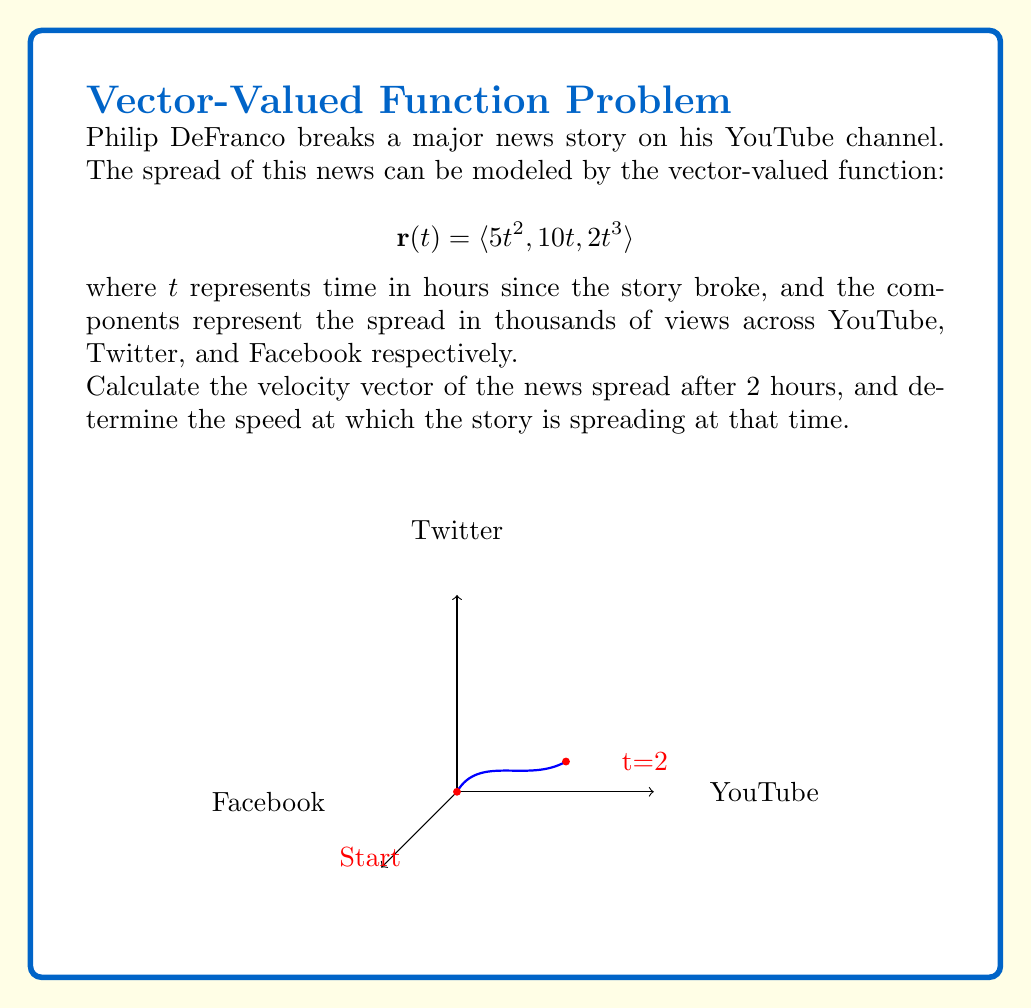Help me with this question. Let's approach this step-by-step:

1) The velocity vector is the derivative of the position vector with respect to time. We need to differentiate each component of $\mathbf{r}(t)$:

   $$\mathbf{v}(t) = \frac{d}{dt}\mathbf{r}(t) = \langle \frac{d}{dt}(5t^2), \frac{d}{dt}(10t), \frac{d}{dt}(2t^3) \rangle$$

2) Applying the differentiation rules:

   $$\mathbf{v}(t) = \langle 10t, 10, 6t^2 \rangle$$

3) We need to find the velocity vector at $t=2$ hours:

   $$\mathbf{v}(2) = \langle 10(2), 10, 6(2^2) \rangle = \langle 20, 10, 24 \rangle$$

4) To find the speed, we need to calculate the magnitude of the velocity vector:

   $$\text{speed} = \|\mathbf{v}(2)\| = \sqrt{20^2 + 10^2 + 24^2}$$

5) Simplifying:

   $$\text{speed} = \sqrt{400 + 100 + 576} = \sqrt{1076} \approx 32.80$$

Therefore, the velocity vector after 2 hours is $\langle 20, 10, 24 \rangle$ thousand views per hour, and the speed at which the story is spreading is approximately 32.80 thousand views per hour.
Answer: Velocity vector: $\langle 20, 10, 24 \rangle$; Speed: $\sqrt{1076} \approx 32.80$ thousand views/hour 